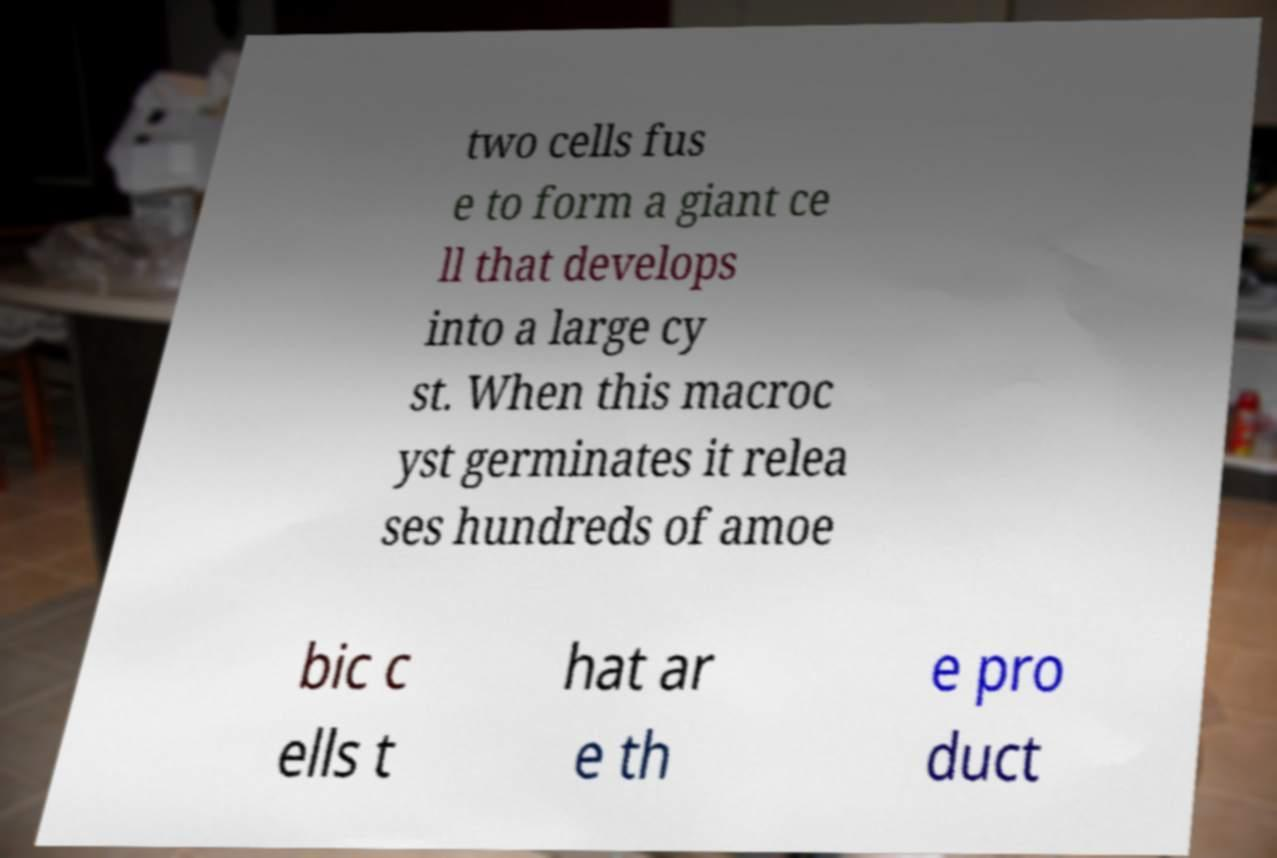What messages or text are displayed in this image? I need them in a readable, typed format. two cells fus e to form a giant ce ll that develops into a large cy st. When this macroc yst germinates it relea ses hundreds of amoe bic c ells t hat ar e th e pro duct 